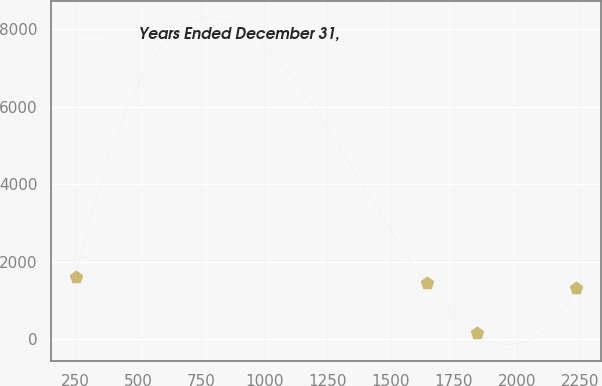Convert chart to OTSL. <chart><loc_0><loc_0><loc_500><loc_500><line_chart><ecel><fcel>Years Ended December 31,<nl><fcel>254.04<fcel>1616.52<nl><fcel>1642.47<fcel>1460.49<nl><fcel>1840.52<fcel>156.73<nl><fcel>2234.56<fcel>1314.51<nl></chart> 